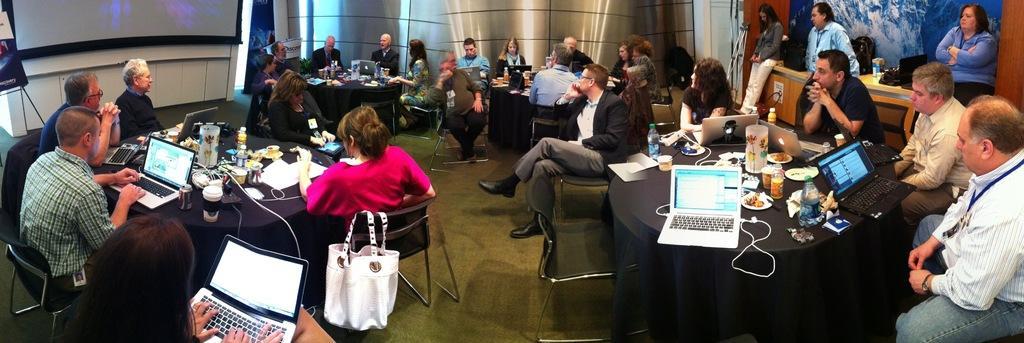In one or two sentences, can you explain what this image depicts? In this image we can see these people are sitting on the chairs near the table where laptops, bottles and few more things are kept. Here we can see the handbag, we can see the projector screen, board to the stand, we can see these people standing near the table in the background. 